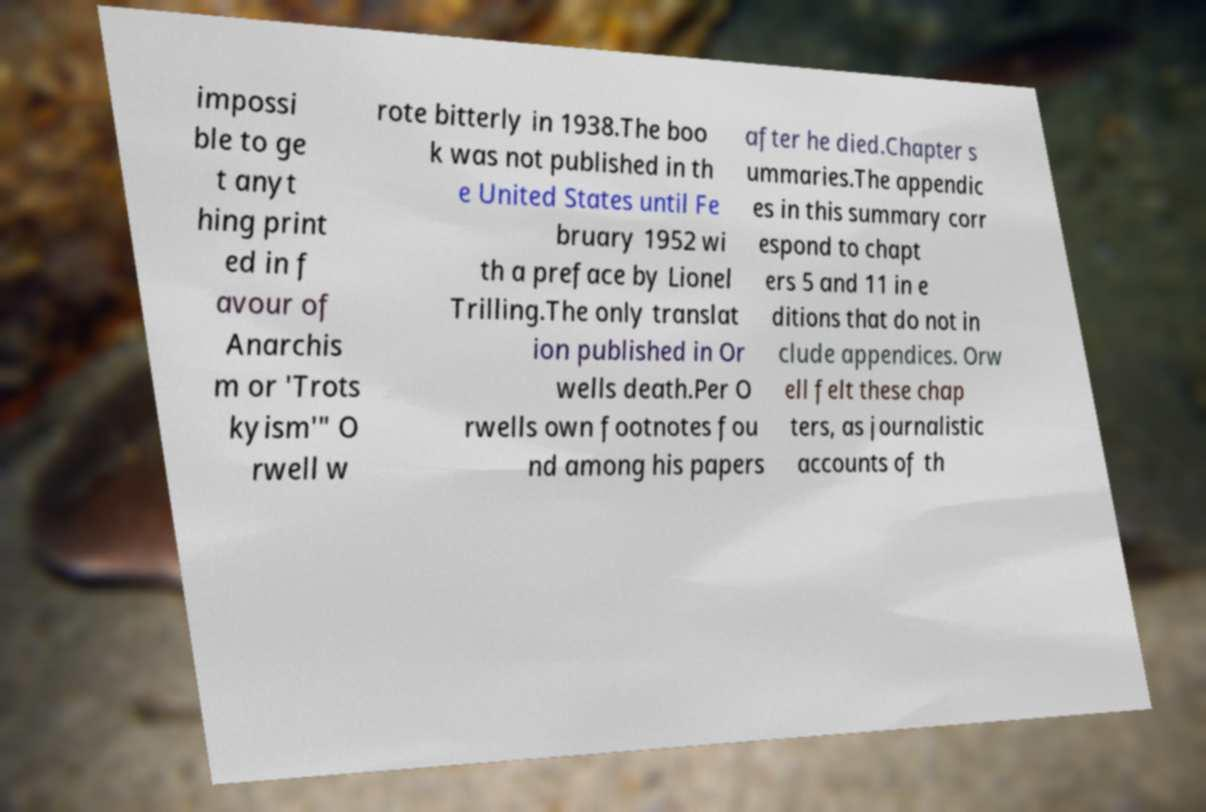Please read and relay the text visible in this image. What does it say? impossi ble to ge t anyt hing print ed in f avour of Anarchis m or 'Trots kyism'" O rwell w rote bitterly in 1938.The boo k was not published in th e United States until Fe bruary 1952 wi th a preface by Lionel Trilling.The only translat ion published in Or wells death.Per O rwells own footnotes fou nd among his papers after he died.Chapter s ummaries.The appendic es in this summary corr espond to chapt ers 5 and 11 in e ditions that do not in clude appendices. Orw ell felt these chap ters, as journalistic accounts of th 